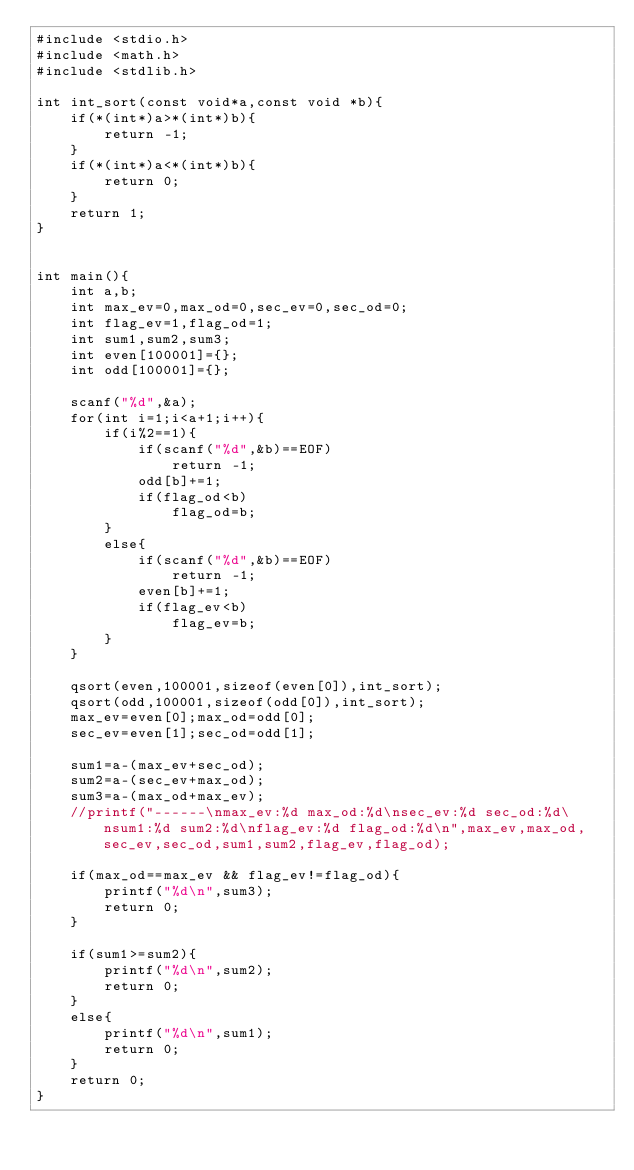Convert code to text. <code><loc_0><loc_0><loc_500><loc_500><_C_>#include <stdio.h>
#include <math.h>
#include <stdlib.h>

int int_sort(const void*a,const void *b){
    if(*(int*)a>*(int*)b){
        return -1;
    }
    if(*(int*)a<*(int*)b){
        return 0;
    }
    return 1;
}


int main(){
    int a,b;
    int max_ev=0,max_od=0,sec_ev=0,sec_od=0;
    int flag_ev=1,flag_od=1;
    int sum1,sum2,sum3;
    int even[100001]={};
    int odd[100001]={};
    
    scanf("%d",&a);
    for(int i=1;i<a+1;i++){
        if(i%2==1){
            if(scanf("%d",&b)==EOF)
                return -1;
            odd[b]+=1;
            if(flag_od<b)
                flag_od=b;
        }
        else{
            if(scanf("%d",&b)==EOF)
                return -1;
            even[b]+=1;
            if(flag_ev<b)
                flag_ev=b;
        }
    }
    
    qsort(even,100001,sizeof(even[0]),int_sort);
    qsort(odd,100001,sizeof(odd[0]),int_sort);
    max_ev=even[0];max_od=odd[0];
    sec_ev=even[1];sec_od=odd[1];
    
    sum1=a-(max_ev+sec_od);
    sum2=a-(sec_ev+max_od);
    sum3=a-(max_od+max_ev);
    //printf("------\nmax_ev:%d max_od:%d\nsec_ev:%d sec_od:%d\nsum1:%d sum2:%d\nflag_ev:%d flag_od:%d\n",max_ev,max_od,sec_ev,sec_od,sum1,sum2,flag_ev,flag_od);
    
    if(max_od==max_ev && flag_ev!=flag_od){
        printf("%d\n",sum3);
        return 0;
    }
    
    if(sum1>=sum2){
        printf("%d\n",sum2);
        return 0;
    }
    else{
        printf("%d\n",sum1);
        return 0;
    }
    return 0;
}
</code> 